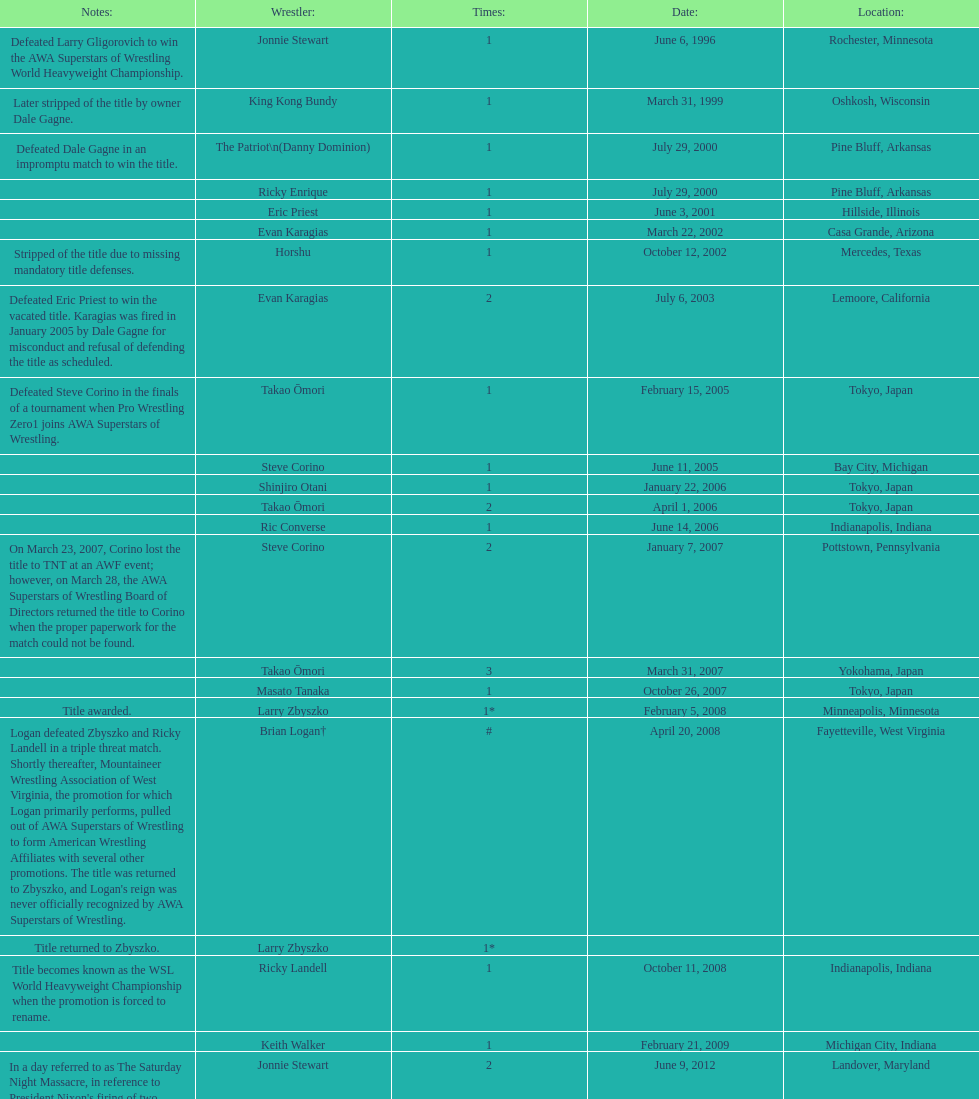What are the number of matches that happened in japan? 5. 